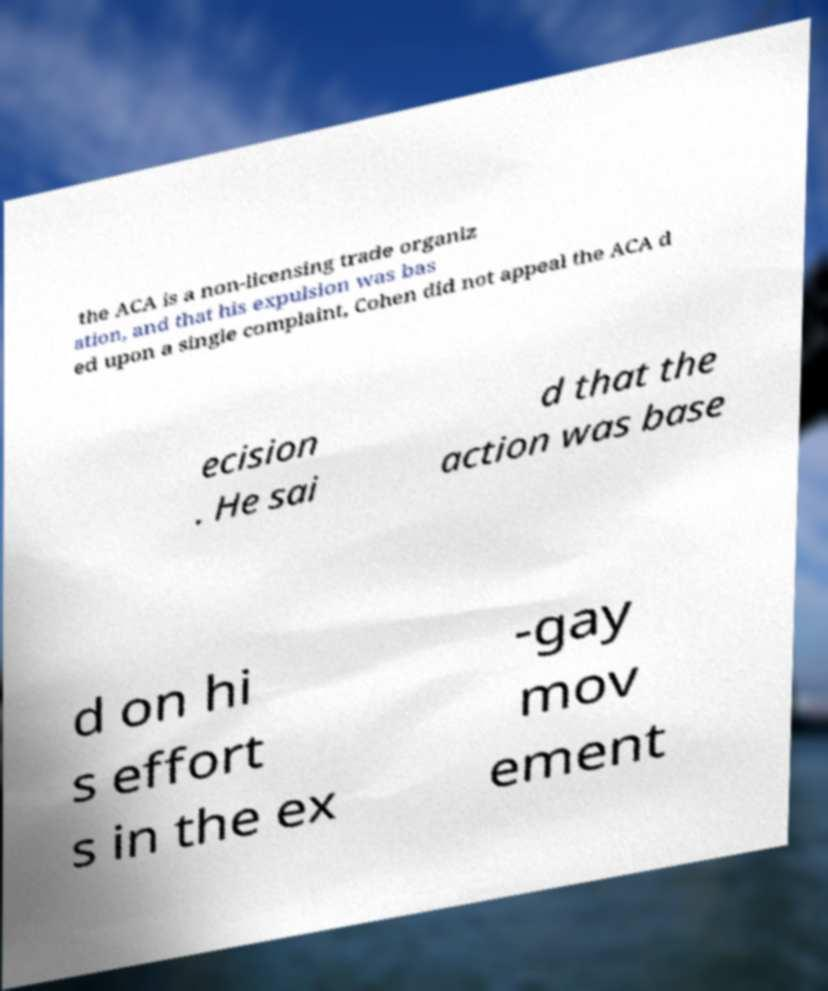There's text embedded in this image that I need extracted. Can you transcribe it verbatim? the ACA is a non-licensing trade organiz ation, and that his expulsion was bas ed upon a single complaint, Cohen did not appeal the ACA d ecision . He sai d that the action was base d on hi s effort s in the ex -gay mov ement 